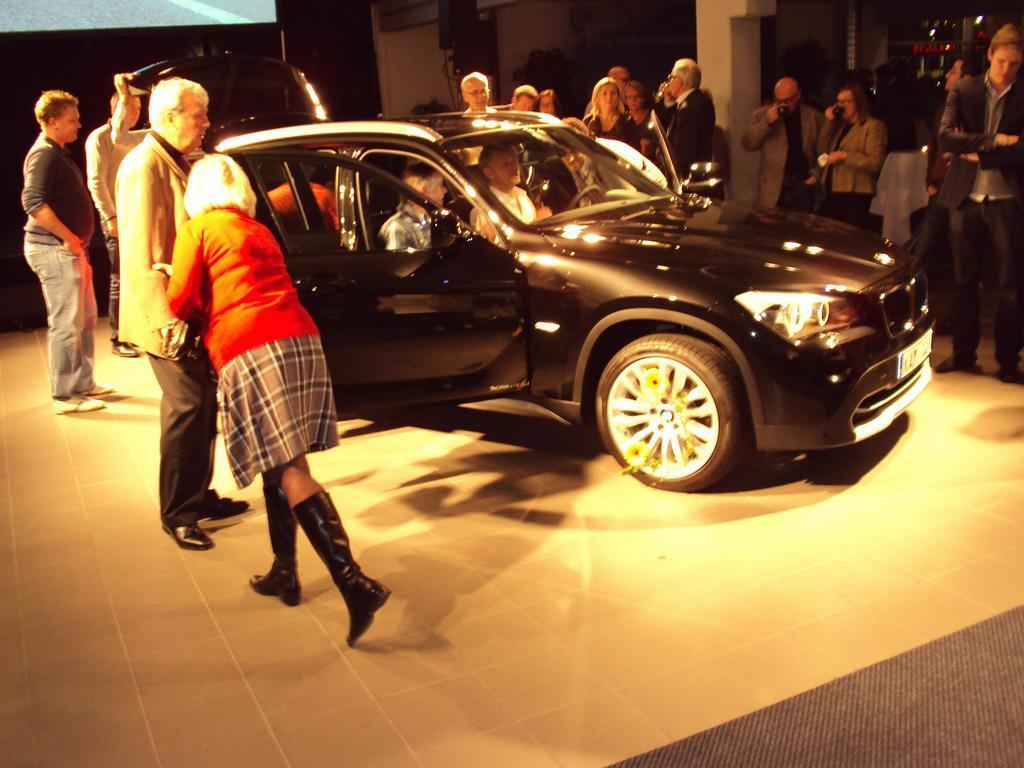Could you give a brief overview of what you see in this image? In this image I can see number of people are standing around this car. I can also see few more people are sitting in car. 